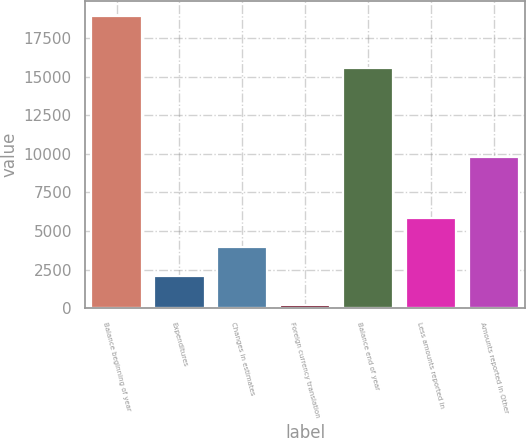Convert chart to OTSL. <chart><loc_0><loc_0><loc_500><loc_500><bar_chart><fcel>Balance beginning of year<fcel>Expenditures<fcel>Changes in estimates<fcel>Foreign currency translation<fcel>Balance end of year<fcel>Less amounts reported in<fcel>Amounts reported in Other<nl><fcel>18970<fcel>2088.7<fcel>3964.4<fcel>213<fcel>15567<fcel>5840.1<fcel>9792<nl></chart> 